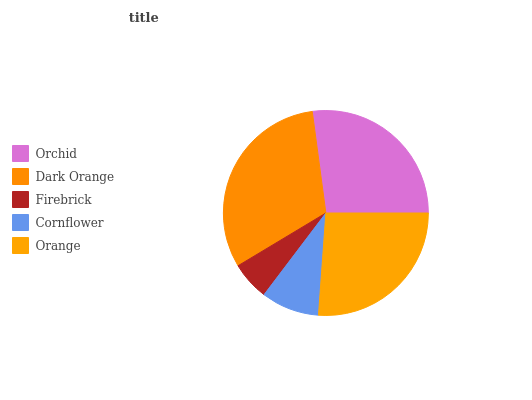Is Firebrick the minimum?
Answer yes or no. Yes. Is Dark Orange the maximum?
Answer yes or no. Yes. Is Dark Orange the minimum?
Answer yes or no. No. Is Firebrick the maximum?
Answer yes or no. No. Is Dark Orange greater than Firebrick?
Answer yes or no. Yes. Is Firebrick less than Dark Orange?
Answer yes or no. Yes. Is Firebrick greater than Dark Orange?
Answer yes or no. No. Is Dark Orange less than Firebrick?
Answer yes or no. No. Is Orange the high median?
Answer yes or no. Yes. Is Orange the low median?
Answer yes or no. Yes. Is Cornflower the high median?
Answer yes or no. No. Is Orchid the low median?
Answer yes or no. No. 